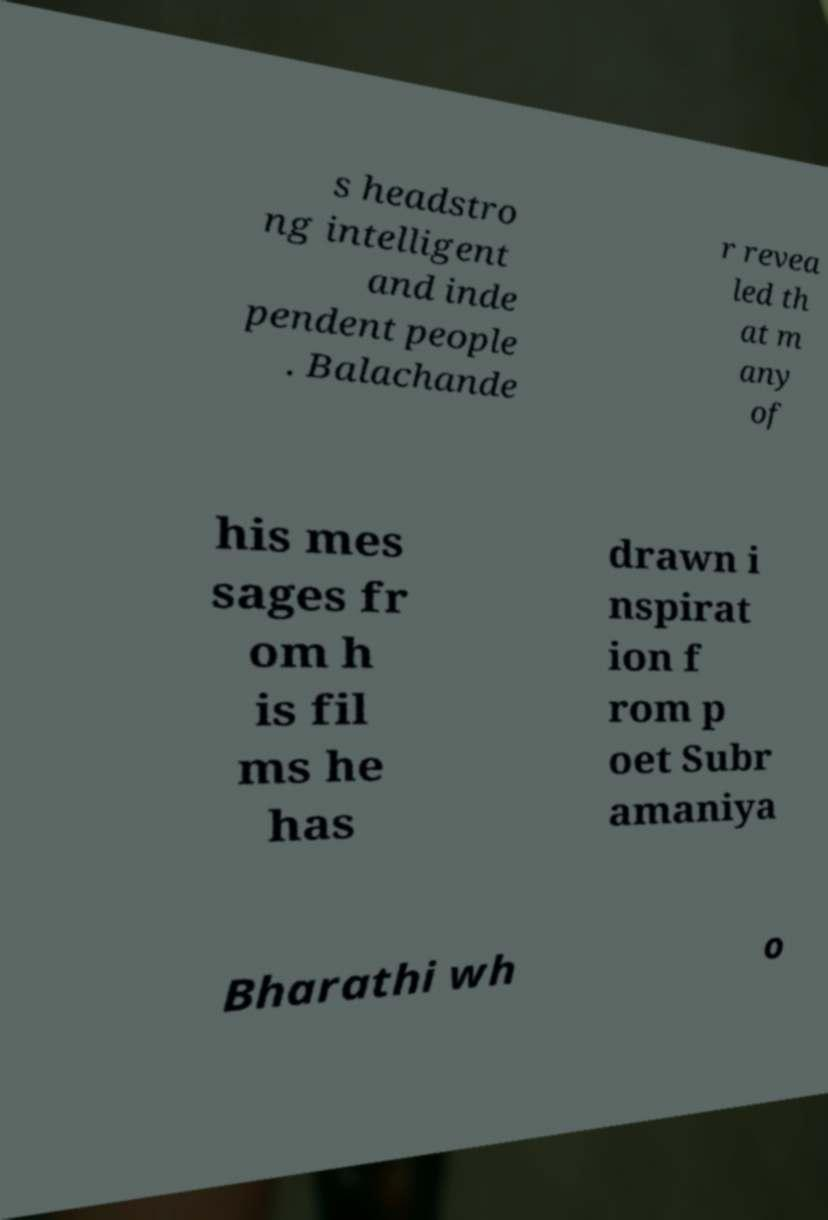Could you assist in decoding the text presented in this image and type it out clearly? s headstro ng intelligent and inde pendent people . Balachande r revea led th at m any of his mes sages fr om h is fil ms he has drawn i nspirat ion f rom p oet Subr amaniya Bharathi wh o 